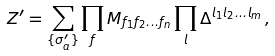Convert formula to latex. <formula><loc_0><loc_0><loc_500><loc_500>Z ^ { \prime } = \sum _ { \{ \sigma ^ { \prime } _ { a } \} } \prod _ { f } M _ { f _ { 1 } f _ { 2 } \dots f _ { n } } \prod _ { l } \Delta ^ { l _ { 1 } l _ { 2 } \dots l _ { m } } \, ,</formula> 